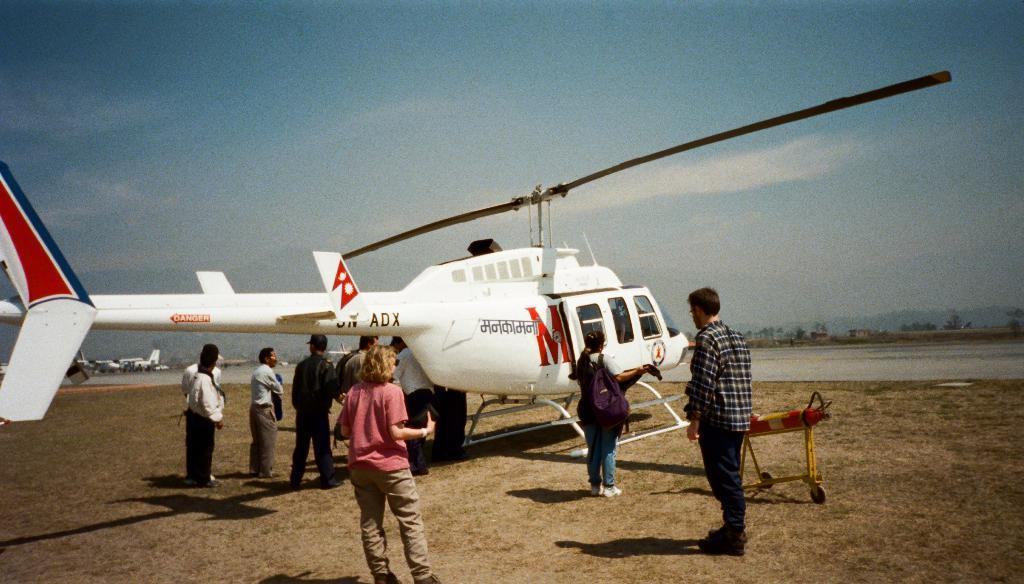<image>
Give a short and clear explanation of the subsequent image. Red M logo on a white helicopter with A D X wrote on the side. 